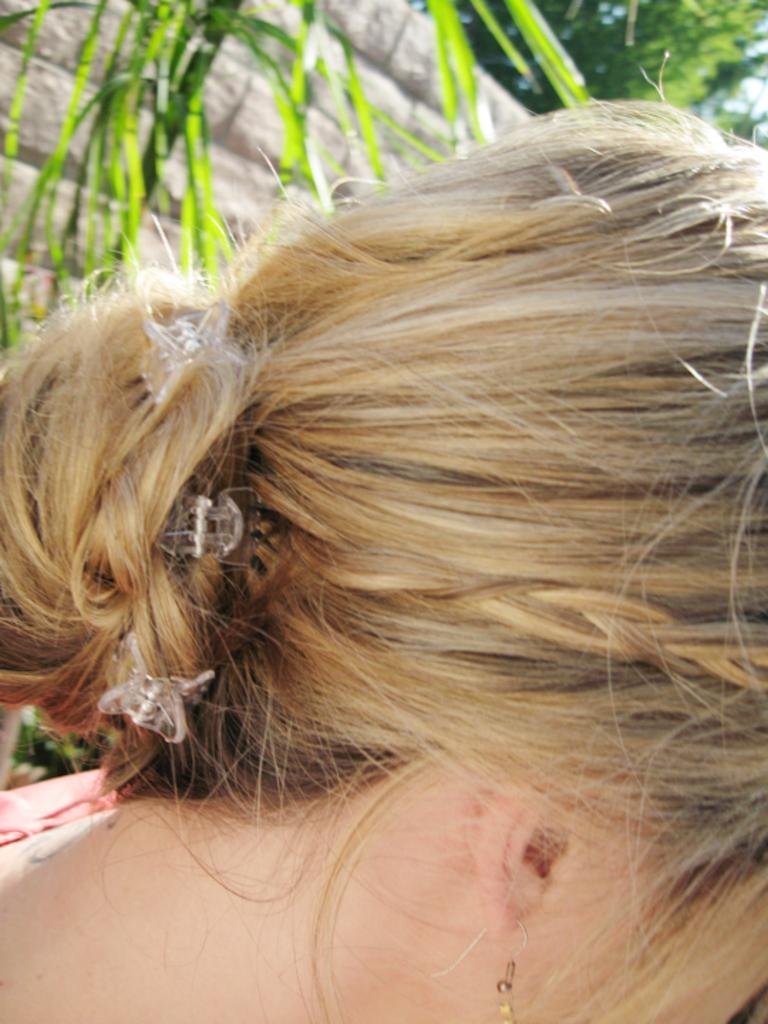Who is the main subject in the image? There is a woman in the front of the image. What can be seen in the background of the image? There is a wall and a tree in the background of the image. Are there any additional details visible in the background? Yes, there are leaves in front of the wall in the background of the image. What type of prose is being recited by the woman in the image? There is: There is no indication in the image that the woman is reciting any prose. 